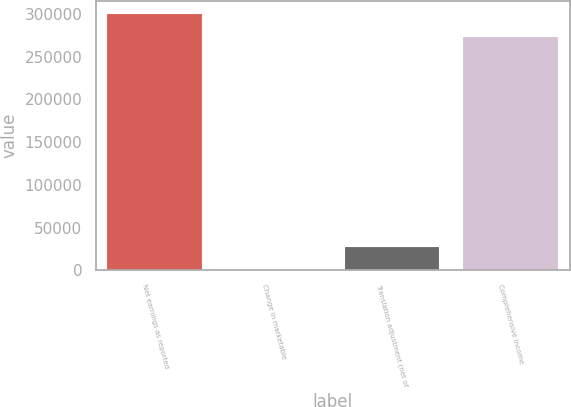Convert chart. <chart><loc_0><loc_0><loc_500><loc_500><bar_chart><fcel>Net earnings as reported<fcel>Change in marketable<fcel>Translation adjustment (net of<fcel>Comprehensive income<nl><fcel>300252<fcel>10<fcel>27979.5<fcel>272283<nl></chart> 